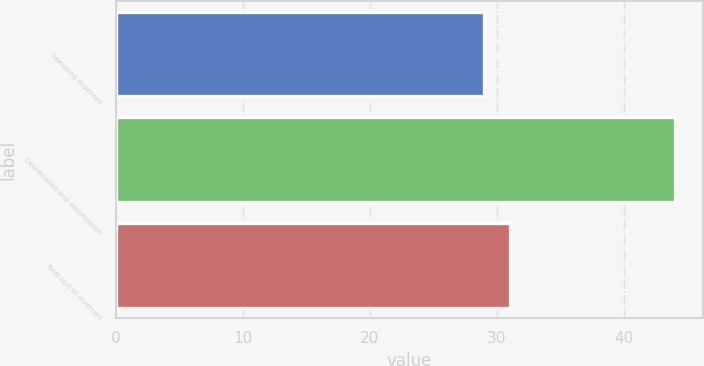Convert chart to OTSL. <chart><loc_0><loc_0><loc_500><loc_500><bar_chart><fcel>Operating expenses<fcel>Depreciation and amortization<fcel>Total cost of revenues<nl><fcel>29<fcel>44<fcel>31<nl></chart> 